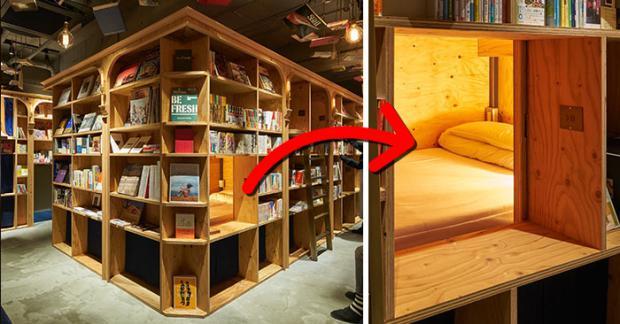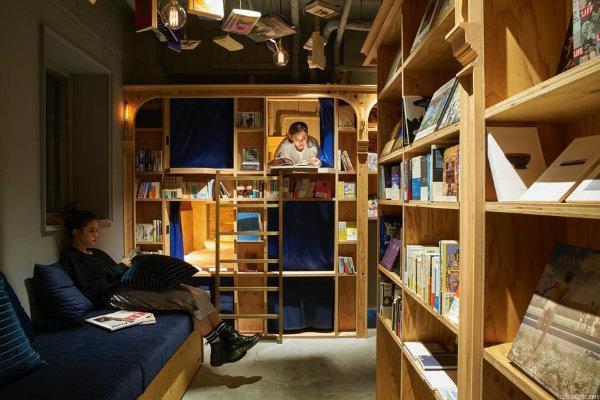The first image is the image on the left, the second image is the image on the right. Given the left and right images, does the statement "There is someone sitting on a blue cushion." hold true? Answer yes or no. Yes. 